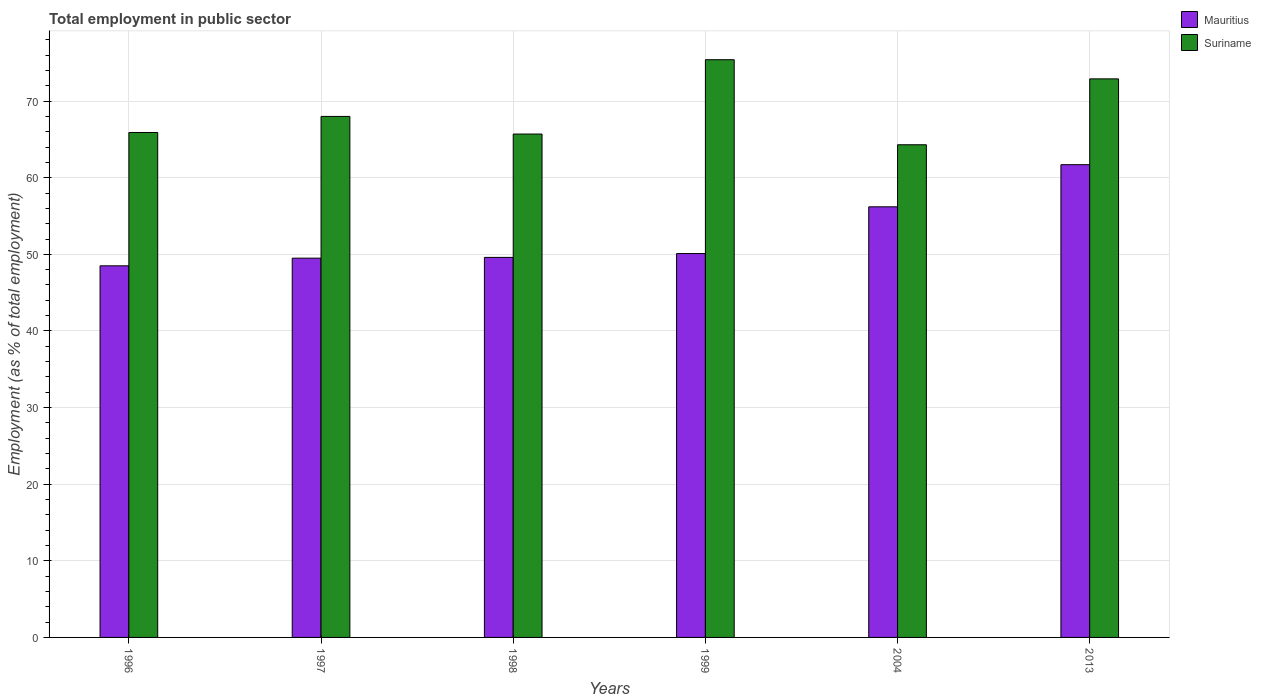Are the number of bars per tick equal to the number of legend labels?
Your answer should be compact. Yes. Are the number of bars on each tick of the X-axis equal?
Your answer should be very brief. Yes. How many bars are there on the 2nd tick from the right?
Keep it short and to the point. 2. What is the employment in public sector in Suriname in 1998?
Provide a succinct answer. 65.7. Across all years, what is the maximum employment in public sector in Suriname?
Give a very brief answer. 75.4. Across all years, what is the minimum employment in public sector in Mauritius?
Give a very brief answer. 48.5. What is the total employment in public sector in Suriname in the graph?
Ensure brevity in your answer.  412.2. What is the difference between the employment in public sector in Mauritius in 1997 and that in 2004?
Provide a short and direct response. -6.7. What is the difference between the employment in public sector in Mauritius in 1998 and the employment in public sector in Suriname in 1996?
Keep it short and to the point. -16.3. What is the average employment in public sector in Mauritius per year?
Ensure brevity in your answer.  52.6. In the year 1996, what is the difference between the employment in public sector in Suriname and employment in public sector in Mauritius?
Provide a short and direct response. 17.4. In how many years, is the employment in public sector in Suriname greater than 2 %?
Ensure brevity in your answer.  6. What is the ratio of the employment in public sector in Suriname in 1997 to that in 1999?
Offer a very short reply. 0.9. Is the difference between the employment in public sector in Suriname in 1996 and 1997 greater than the difference between the employment in public sector in Mauritius in 1996 and 1997?
Offer a terse response. No. What is the difference between the highest and the lowest employment in public sector in Mauritius?
Keep it short and to the point. 13.2. Is the sum of the employment in public sector in Suriname in 1996 and 1998 greater than the maximum employment in public sector in Mauritius across all years?
Ensure brevity in your answer.  Yes. What does the 2nd bar from the left in 1996 represents?
Provide a succinct answer. Suriname. What does the 1st bar from the right in 1999 represents?
Provide a succinct answer. Suriname. How many bars are there?
Your answer should be very brief. 12. What is the difference between two consecutive major ticks on the Y-axis?
Provide a short and direct response. 10. Are the values on the major ticks of Y-axis written in scientific E-notation?
Offer a terse response. No. Does the graph contain any zero values?
Offer a very short reply. No. Does the graph contain grids?
Keep it short and to the point. Yes. What is the title of the graph?
Ensure brevity in your answer.  Total employment in public sector. Does "Niger" appear as one of the legend labels in the graph?
Your response must be concise. No. What is the label or title of the X-axis?
Provide a succinct answer. Years. What is the label or title of the Y-axis?
Offer a very short reply. Employment (as % of total employment). What is the Employment (as % of total employment) of Mauritius in 1996?
Provide a succinct answer. 48.5. What is the Employment (as % of total employment) in Suriname in 1996?
Provide a succinct answer. 65.9. What is the Employment (as % of total employment) of Mauritius in 1997?
Give a very brief answer. 49.5. What is the Employment (as % of total employment) in Mauritius in 1998?
Provide a succinct answer. 49.6. What is the Employment (as % of total employment) of Suriname in 1998?
Your answer should be compact. 65.7. What is the Employment (as % of total employment) of Mauritius in 1999?
Your answer should be compact. 50.1. What is the Employment (as % of total employment) of Suriname in 1999?
Make the answer very short. 75.4. What is the Employment (as % of total employment) of Mauritius in 2004?
Provide a succinct answer. 56.2. What is the Employment (as % of total employment) of Suriname in 2004?
Give a very brief answer. 64.3. What is the Employment (as % of total employment) of Mauritius in 2013?
Ensure brevity in your answer.  61.7. What is the Employment (as % of total employment) in Suriname in 2013?
Offer a very short reply. 72.9. Across all years, what is the maximum Employment (as % of total employment) of Mauritius?
Your response must be concise. 61.7. Across all years, what is the maximum Employment (as % of total employment) in Suriname?
Ensure brevity in your answer.  75.4. Across all years, what is the minimum Employment (as % of total employment) in Mauritius?
Make the answer very short. 48.5. Across all years, what is the minimum Employment (as % of total employment) in Suriname?
Make the answer very short. 64.3. What is the total Employment (as % of total employment) in Mauritius in the graph?
Keep it short and to the point. 315.6. What is the total Employment (as % of total employment) of Suriname in the graph?
Give a very brief answer. 412.2. What is the difference between the Employment (as % of total employment) in Mauritius in 1996 and that in 1997?
Make the answer very short. -1. What is the difference between the Employment (as % of total employment) of Mauritius in 1996 and that in 2004?
Offer a terse response. -7.7. What is the difference between the Employment (as % of total employment) of Suriname in 1996 and that in 2004?
Offer a terse response. 1.6. What is the difference between the Employment (as % of total employment) of Mauritius in 1996 and that in 2013?
Keep it short and to the point. -13.2. What is the difference between the Employment (as % of total employment) of Suriname in 1996 and that in 2013?
Make the answer very short. -7. What is the difference between the Employment (as % of total employment) of Mauritius in 1997 and that in 1998?
Provide a short and direct response. -0.1. What is the difference between the Employment (as % of total employment) in Suriname in 1997 and that in 1998?
Give a very brief answer. 2.3. What is the difference between the Employment (as % of total employment) in Suriname in 1997 and that in 1999?
Offer a terse response. -7.4. What is the difference between the Employment (as % of total employment) of Mauritius in 1997 and that in 2013?
Offer a terse response. -12.2. What is the difference between the Employment (as % of total employment) in Suriname in 1997 and that in 2013?
Offer a very short reply. -4.9. What is the difference between the Employment (as % of total employment) in Mauritius in 1998 and that in 1999?
Make the answer very short. -0.5. What is the difference between the Employment (as % of total employment) in Suriname in 1998 and that in 1999?
Offer a terse response. -9.7. What is the difference between the Employment (as % of total employment) in Mauritius in 1998 and that in 2004?
Give a very brief answer. -6.6. What is the difference between the Employment (as % of total employment) of Suriname in 1998 and that in 2004?
Ensure brevity in your answer.  1.4. What is the difference between the Employment (as % of total employment) in Suriname in 1999 and that in 2004?
Provide a short and direct response. 11.1. What is the difference between the Employment (as % of total employment) in Mauritius in 2004 and that in 2013?
Your answer should be compact. -5.5. What is the difference between the Employment (as % of total employment) of Mauritius in 1996 and the Employment (as % of total employment) of Suriname in 1997?
Your answer should be very brief. -19.5. What is the difference between the Employment (as % of total employment) of Mauritius in 1996 and the Employment (as % of total employment) of Suriname in 1998?
Provide a succinct answer. -17.2. What is the difference between the Employment (as % of total employment) of Mauritius in 1996 and the Employment (as % of total employment) of Suriname in 1999?
Ensure brevity in your answer.  -26.9. What is the difference between the Employment (as % of total employment) in Mauritius in 1996 and the Employment (as % of total employment) in Suriname in 2004?
Keep it short and to the point. -15.8. What is the difference between the Employment (as % of total employment) in Mauritius in 1996 and the Employment (as % of total employment) in Suriname in 2013?
Your response must be concise. -24.4. What is the difference between the Employment (as % of total employment) in Mauritius in 1997 and the Employment (as % of total employment) in Suriname in 1998?
Provide a succinct answer. -16.2. What is the difference between the Employment (as % of total employment) in Mauritius in 1997 and the Employment (as % of total employment) in Suriname in 1999?
Give a very brief answer. -25.9. What is the difference between the Employment (as % of total employment) of Mauritius in 1997 and the Employment (as % of total employment) of Suriname in 2004?
Make the answer very short. -14.8. What is the difference between the Employment (as % of total employment) of Mauritius in 1997 and the Employment (as % of total employment) of Suriname in 2013?
Provide a short and direct response. -23.4. What is the difference between the Employment (as % of total employment) of Mauritius in 1998 and the Employment (as % of total employment) of Suriname in 1999?
Offer a terse response. -25.8. What is the difference between the Employment (as % of total employment) of Mauritius in 1998 and the Employment (as % of total employment) of Suriname in 2004?
Offer a terse response. -14.7. What is the difference between the Employment (as % of total employment) of Mauritius in 1998 and the Employment (as % of total employment) of Suriname in 2013?
Offer a terse response. -23.3. What is the difference between the Employment (as % of total employment) of Mauritius in 1999 and the Employment (as % of total employment) of Suriname in 2013?
Your answer should be compact. -22.8. What is the difference between the Employment (as % of total employment) in Mauritius in 2004 and the Employment (as % of total employment) in Suriname in 2013?
Offer a terse response. -16.7. What is the average Employment (as % of total employment) of Mauritius per year?
Provide a succinct answer. 52.6. What is the average Employment (as % of total employment) of Suriname per year?
Ensure brevity in your answer.  68.7. In the year 1996, what is the difference between the Employment (as % of total employment) in Mauritius and Employment (as % of total employment) in Suriname?
Offer a very short reply. -17.4. In the year 1997, what is the difference between the Employment (as % of total employment) in Mauritius and Employment (as % of total employment) in Suriname?
Offer a very short reply. -18.5. In the year 1998, what is the difference between the Employment (as % of total employment) in Mauritius and Employment (as % of total employment) in Suriname?
Make the answer very short. -16.1. In the year 1999, what is the difference between the Employment (as % of total employment) in Mauritius and Employment (as % of total employment) in Suriname?
Offer a very short reply. -25.3. In the year 2013, what is the difference between the Employment (as % of total employment) of Mauritius and Employment (as % of total employment) of Suriname?
Your response must be concise. -11.2. What is the ratio of the Employment (as % of total employment) of Mauritius in 1996 to that in 1997?
Give a very brief answer. 0.98. What is the ratio of the Employment (as % of total employment) in Suriname in 1996 to that in 1997?
Offer a very short reply. 0.97. What is the ratio of the Employment (as % of total employment) in Mauritius in 1996 to that in 1998?
Make the answer very short. 0.98. What is the ratio of the Employment (as % of total employment) of Mauritius in 1996 to that in 1999?
Provide a short and direct response. 0.97. What is the ratio of the Employment (as % of total employment) in Suriname in 1996 to that in 1999?
Your response must be concise. 0.87. What is the ratio of the Employment (as % of total employment) in Mauritius in 1996 to that in 2004?
Your answer should be very brief. 0.86. What is the ratio of the Employment (as % of total employment) in Suriname in 1996 to that in 2004?
Make the answer very short. 1.02. What is the ratio of the Employment (as % of total employment) in Mauritius in 1996 to that in 2013?
Offer a very short reply. 0.79. What is the ratio of the Employment (as % of total employment) in Suriname in 1996 to that in 2013?
Offer a terse response. 0.9. What is the ratio of the Employment (as % of total employment) of Mauritius in 1997 to that in 1998?
Make the answer very short. 1. What is the ratio of the Employment (as % of total employment) of Suriname in 1997 to that in 1998?
Make the answer very short. 1.03. What is the ratio of the Employment (as % of total employment) in Suriname in 1997 to that in 1999?
Ensure brevity in your answer.  0.9. What is the ratio of the Employment (as % of total employment) of Mauritius in 1997 to that in 2004?
Your answer should be compact. 0.88. What is the ratio of the Employment (as % of total employment) in Suriname in 1997 to that in 2004?
Keep it short and to the point. 1.06. What is the ratio of the Employment (as % of total employment) of Mauritius in 1997 to that in 2013?
Provide a short and direct response. 0.8. What is the ratio of the Employment (as % of total employment) in Suriname in 1997 to that in 2013?
Your answer should be compact. 0.93. What is the ratio of the Employment (as % of total employment) in Mauritius in 1998 to that in 1999?
Make the answer very short. 0.99. What is the ratio of the Employment (as % of total employment) of Suriname in 1998 to that in 1999?
Make the answer very short. 0.87. What is the ratio of the Employment (as % of total employment) in Mauritius in 1998 to that in 2004?
Offer a very short reply. 0.88. What is the ratio of the Employment (as % of total employment) of Suriname in 1998 to that in 2004?
Provide a short and direct response. 1.02. What is the ratio of the Employment (as % of total employment) in Mauritius in 1998 to that in 2013?
Provide a succinct answer. 0.8. What is the ratio of the Employment (as % of total employment) of Suriname in 1998 to that in 2013?
Make the answer very short. 0.9. What is the ratio of the Employment (as % of total employment) in Mauritius in 1999 to that in 2004?
Offer a terse response. 0.89. What is the ratio of the Employment (as % of total employment) in Suriname in 1999 to that in 2004?
Ensure brevity in your answer.  1.17. What is the ratio of the Employment (as % of total employment) in Mauritius in 1999 to that in 2013?
Your answer should be very brief. 0.81. What is the ratio of the Employment (as % of total employment) in Suriname in 1999 to that in 2013?
Keep it short and to the point. 1.03. What is the ratio of the Employment (as % of total employment) of Mauritius in 2004 to that in 2013?
Your response must be concise. 0.91. What is the ratio of the Employment (as % of total employment) in Suriname in 2004 to that in 2013?
Offer a terse response. 0.88. What is the difference between the highest and the lowest Employment (as % of total employment) of Mauritius?
Provide a short and direct response. 13.2. 